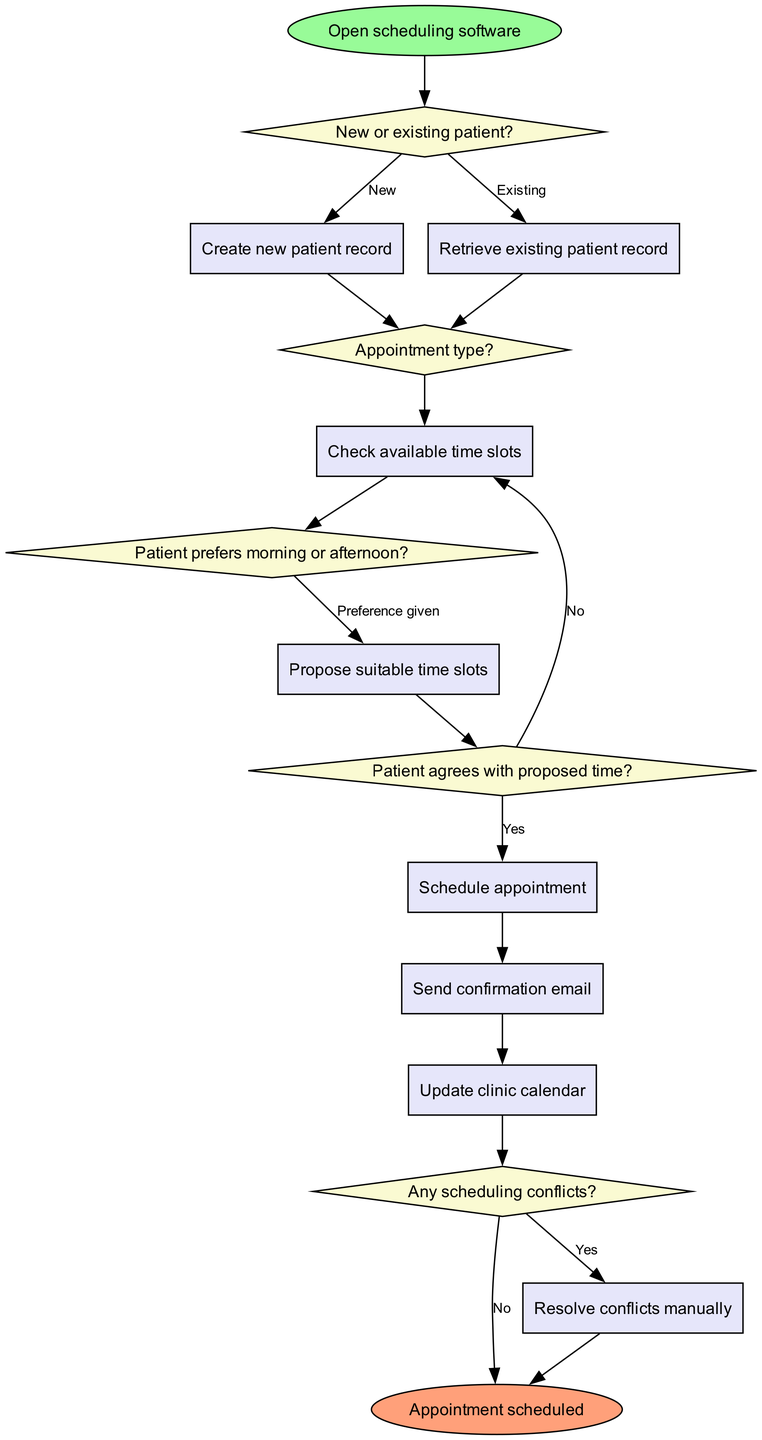What is the first step in the scheduling process? The first step in the diagram is represented by the 'start' node, which is "Open scheduling software." This indicates what action initiates the appointment scheduling process.
Answer: Open scheduling software How many decision nodes are there in the diagram? The diagram contains five decision nodes, which include decisions regarding whether the patient is new or existing, the appointment type, patient preference for morning or afternoon, agreement on proposed time, and any scheduling conflicts.
Answer: Five What happens if the patient prefers a morning appointment? If the patient prefers a morning appointment, the flow moves from 'decision3' to 'process4', which is where suitable time slots are proposed. The diagram indicates that the patient's preference is addressed at this stage.
Answer: Propose suitable time slots What is the outcome if there are no scheduling conflicts? If there are no scheduling conflicts, the flow moves from 'decision5' directly to the 'end' node, indicating that the appointment is successfully scheduled. This shows the path taken when there are no issues to resolve.
Answer: Appointment scheduled What occurs after scheduling the appointment? Once the appointment is scheduled, the next step in the process is to send a confirmation email, as indicated by the flow from 'process5' to 'process6.' This step is crucial for ensuring the patient is informed.
Answer: Send confirmation email What is the last step in the process flow? The last step in the process flow is represented by the 'end' node, which indicates the completion of the scheduling process, meaning all actions have been finalized. This confirms that the appointment management is concluded.
Answer: Appointment scheduled What must happen if the patient disagrees with the proposed time? If the patient disagrees with the proposed time, the flow returns to 'process3' to check for other available time slots, indicating a loop to accommodate patient preferences. This shows the iterative nature of finding suitable times.
Answer: Check available time slots Which node follows after retrieving an existing patient record? After retrieving an existing patient record, the flow moves to 'decision2,' which is concerned with determining the type of appointment needed. This shows the continuity of the process focused on the patient's existing record.
Answer: Appointment type 